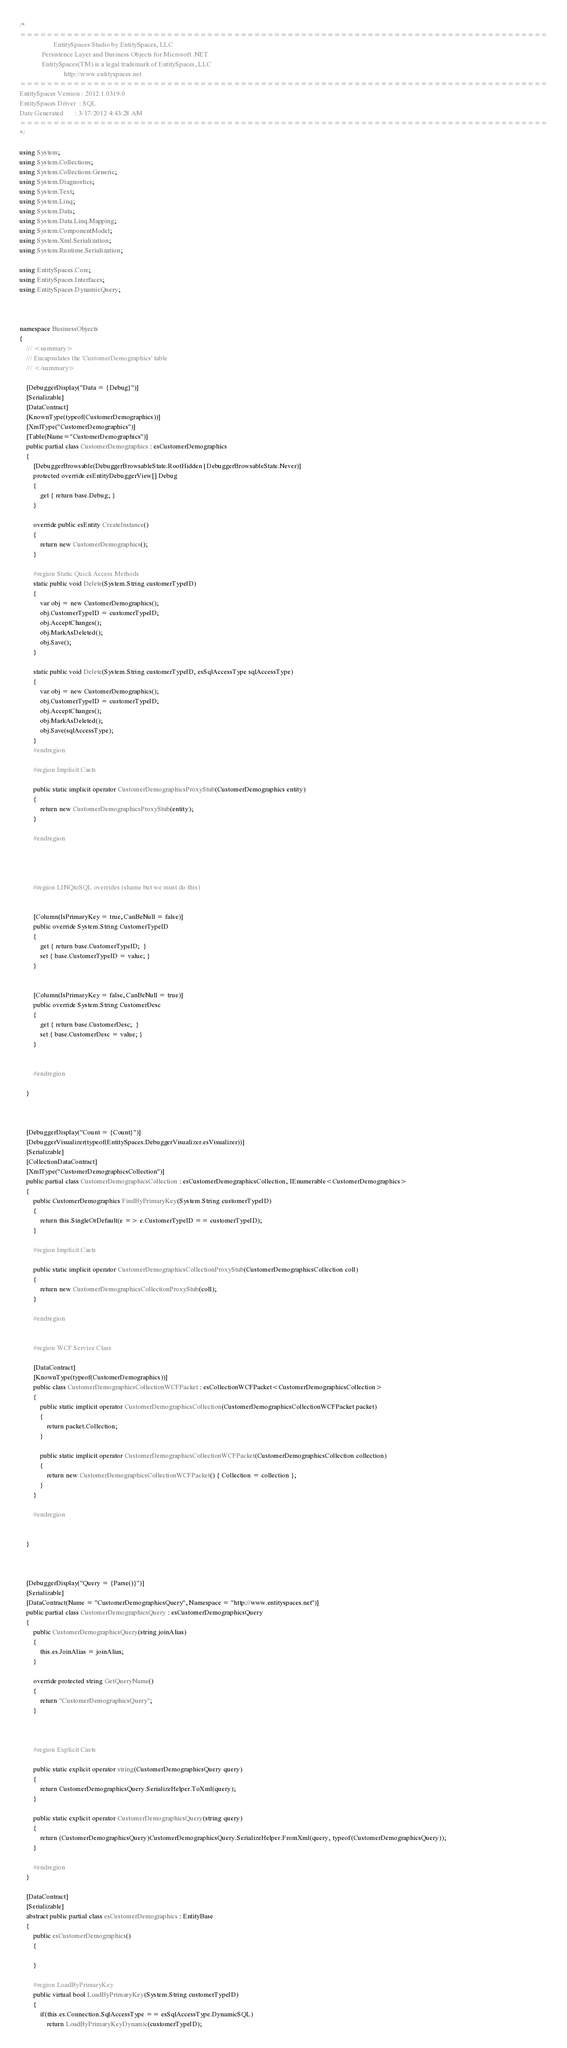<code> <loc_0><loc_0><loc_500><loc_500><_C#_>
/*
===============================================================================
                    EntitySpaces Studio by EntitySpaces, LLC
             Persistence Layer and Business Objects for Microsoft .NET
             EntitySpaces(TM) is a legal trademark of EntitySpaces, LLC
                          http://www.entityspaces.net
===============================================================================
EntitySpaces Version : 2012.1.0319.0
EntitySpaces Driver  : SQL
Date Generated       : 3/17/2012 4:43:28 AM
===============================================================================
*/

using System;
using System.Collections;
using System.Collections.Generic;
using System.Diagnostics;
using System.Text;
using System.Linq;
using System.Data;
using System.Data.Linq.Mapping;
using System.ComponentModel;
using System.Xml.Serialization;
using System.Runtime.Serialization;

using EntitySpaces.Core;
using EntitySpaces.Interfaces;
using EntitySpaces.DynamicQuery;



namespace BusinessObjects
{
	/// <summary>
	/// Encapsulates the 'CustomerDemographics' table
	/// </summary>

    [DebuggerDisplay("Data = {Debug}")]
	[Serializable]
	[DataContract]
	[KnownType(typeof(CustomerDemographics))]	
	[XmlType("CustomerDemographics")]
	[Table(Name="CustomerDemographics")]
	public partial class CustomerDemographics : esCustomerDemographics
	{	
		[DebuggerBrowsable(DebuggerBrowsableState.RootHidden | DebuggerBrowsableState.Never)]
		protected override esEntityDebuggerView[] Debug
		{
			get { return base.Debug; }
		}

		override public esEntity CreateInstance()
		{
			return new CustomerDemographics();
		}
		
		#region Static Quick Access Methods
		static public void Delete(System.String customerTypeID)
		{
			var obj = new CustomerDemographics();
			obj.CustomerTypeID = customerTypeID;
			obj.AcceptChanges();
			obj.MarkAsDeleted();
			obj.Save();
		}

	    static public void Delete(System.String customerTypeID, esSqlAccessType sqlAccessType)
		{
			var obj = new CustomerDemographics();
			obj.CustomerTypeID = customerTypeID;
			obj.AcceptChanges();
			obj.MarkAsDeleted();
			obj.Save(sqlAccessType);
		}
		#endregion

		#region Implicit Casts

		public static implicit operator CustomerDemographicsProxyStub(CustomerDemographics entity)
		{
			return new CustomerDemographicsProxyStub(entity);
		}

		#endregion
		
					
		

		#region LINQtoSQL overrides (shame but we must do this)

			
		[Column(IsPrimaryKey = true, CanBeNull = false)]
		public override System.String CustomerTypeID
		{
			get { return base.CustomerTypeID;  }
			set { base.CustomerTypeID = value; }
		}

			
		[Column(IsPrimaryKey = false, CanBeNull = true)]
		public override System.String CustomerDesc
		{
			get { return base.CustomerDesc;  }
			set { base.CustomerDesc = value; }
		}


		#endregion
	
	}



    [DebuggerDisplay("Count = {Count}")]
	[DebuggerVisualizer(typeof(EntitySpaces.DebuggerVisualizer.esVisualizer))]
	[Serializable]
	[CollectionDataContract]
	[XmlType("CustomerDemographicsCollection")]
	public partial class CustomerDemographicsCollection : esCustomerDemographicsCollection, IEnumerable<CustomerDemographics>
	{
		public CustomerDemographics FindByPrimaryKey(System.String customerTypeID)
		{
			return this.SingleOrDefault(e => e.CustomerTypeID == customerTypeID);
		}

		#region Implicit Casts
		
		public static implicit operator CustomerDemographicsCollectionProxyStub(CustomerDemographicsCollection coll)
		{
			return new CustomerDemographicsCollectionProxyStub(coll);
		}
		
		#endregion
		
		
		#region WCF Service Class
		
		[DataContract]
		[KnownType(typeof(CustomerDemographics))]
		public class CustomerDemographicsCollectionWCFPacket : esCollectionWCFPacket<CustomerDemographicsCollection>
		{
			public static implicit operator CustomerDemographicsCollection(CustomerDemographicsCollectionWCFPacket packet)
			{
				return packet.Collection;
			}

			public static implicit operator CustomerDemographicsCollectionWCFPacket(CustomerDemographicsCollection collection)
			{
				return new CustomerDemographicsCollectionWCFPacket() { Collection = collection };
			}
		}
		
		#endregion
		
				
	}



    [DebuggerDisplay("Query = {Parse()}")]
	[Serializable]
	[DataContract(Name = "CustomerDemographicsQuery", Namespace = "http://www.entityspaces.net")]	
	public partial class CustomerDemographicsQuery : esCustomerDemographicsQuery
	{
		public CustomerDemographicsQuery(string joinAlias)
		{
			this.es.JoinAlias = joinAlias;
		}	

		override protected string GetQueryName()
		{
			return "CustomerDemographicsQuery";
		}
		
					
	
		#region Explicit Casts
		
		public static explicit operator string(CustomerDemographicsQuery query)
		{
			return CustomerDemographicsQuery.SerializeHelper.ToXml(query);
		}

		public static explicit operator CustomerDemographicsQuery(string query)
		{
			return (CustomerDemographicsQuery)CustomerDemographicsQuery.SerializeHelper.FromXml(query, typeof(CustomerDemographicsQuery));
		}
		
		#endregion		
	}

	[DataContract]
	[Serializable]
	abstract public partial class esCustomerDemographics : EntityBase
	{
		public esCustomerDemographics()
		{

		}
		
		#region LoadByPrimaryKey
		public virtual bool LoadByPrimaryKey(System.String customerTypeID)
		{
			if(this.es.Connection.SqlAccessType == esSqlAccessType.DynamicSQL)
				return LoadByPrimaryKeyDynamic(customerTypeID);</code> 